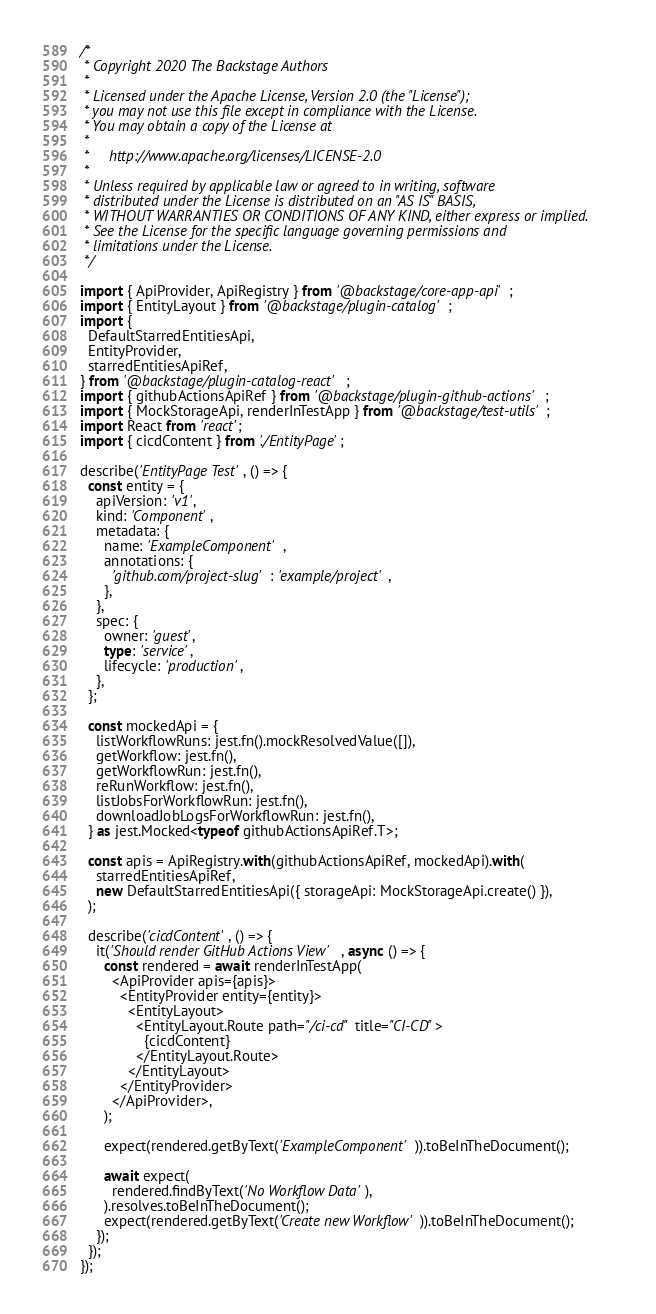Convert code to text. <code><loc_0><loc_0><loc_500><loc_500><_TypeScript_>/*
 * Copyright 2020 The Backstage Authors
 *
 * Licensed under the Apache License, Version 2.0 (the "License");
 * you may not use this file except in compliance with the License.
 * You may obtain a copy of the License at
 *
 *     http://www.apache.org/licenses/LICENSE-2.0
 *
 * Unless required by applicable law or agreed to in writing, software
 * distributed under the License is distributed on an "AS IS" BASIS,
 * WITHOUT WARRANTIES OR CONDITIONS OF ANY KIND, either express or implied.
 * See the License for the specific language governing permissions and
 * limitations under the License.
 */

import { ApiProvider, ApiRegistry } from '@backstage/core-app-api';
import { EntityLayout } from '@backstage/plugin-catalog';
import {
  DefaultStarredEntitiesApi,
  EntityProvider,
  starredEntitiesApiRef,
} from '@backstage/plugin-catalog-react';
import { githubActionsApiRef } from '@backstage/plugin-github-actions';
import { MockStorageApi, renderInTestApp } from '@backstage/test-utils';
import React from 'react';
import { cicdContent } from './EntityPage';

describe('EntityPage Test', () => {
  const entity = {
    apiVersion: 'v1',
    kind: 'Component',
    metadata: {
      name: 'ExampleComponent',
      annotations: {
        'github.com/project-slug': 'example/project',
      },
    },
    spec: {
      owner: 'guest',
      type: 'service',
      lifecycle: 'production',
    },
  };

  const mockedApi = {
    listWorkflowRuns: jest.fn().mockResolvedValue([]),
    getWorkflow: jest.fn(),
    getWorkflowRun: jest.fn(),
    reRunWorkflow: jest.fn(),
    listJobsForWorkflowRun: jest.fn(),
    downloadJobLogsForWorkflowRun: jest.fn(),
  } as jest.Mocked<typeof githubActionsApiRef.T>;

  const apis = ApiRegistry.with(githubActionsApiRef, mockedApi).with(
    starredEntitiesApiRef,
    new DefaultStarredEntitiesApi({ storageApi: MockStorageApi.create() }),
  );

  describe('cicdContent', () => {
    it('Should render GitHub Actions View', async () => {
      const rendered = await renderInTestApp(
        <ApiProvider apis={apis}>
          <EntityProvider entity={entity}>
            <EntityLayout>
              <EntityLayout.Route path="/ci-cd" title="CI-CD">
                {cicdContent}
              </EntityLayout.Route>
            </EntityLayout>
          </EntityProvider>
        </ApiProvider>,
      );

      expect(rendered.getByText('ExampleComponent')).toBeInTheDocument();

      await expect(
        rendered.findByText('No Workflow Data'),
      ).resolves.toBeInTheDocument();
      expect(rendered.getByText('Create new Workflow')).toBeInTheDocument();
    });
  });
});
</code> 